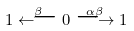Convert formula to latex. <formula><loc_0><loc_0><loc_500><loc_500>1 \stackrel { \beta } { \longleftarrow } 0 \stackrel { \alpha \beta } { \longrightarrow } 1</formula> 